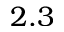<formula> <loc_0><loc_0><loc_500><loc_500>2 . 3</formula> 